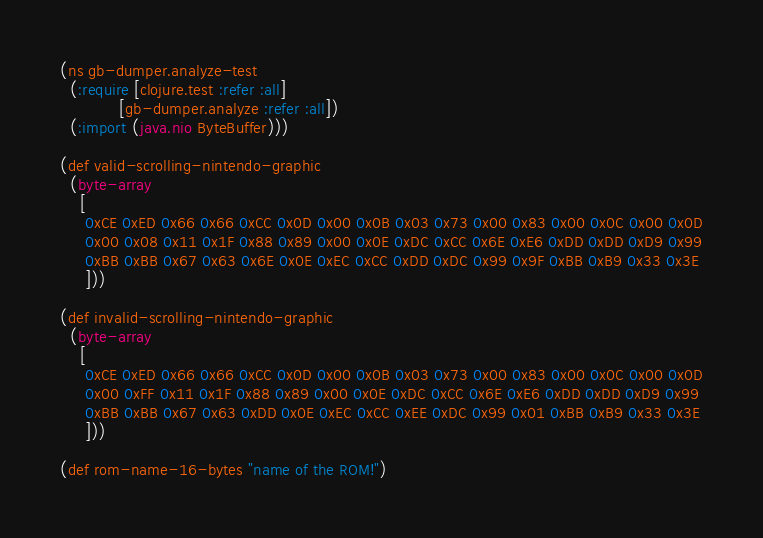<code> <loc_0><loc_0><loc_500><loc_500><_Clojure_>(ns gb-dumper.analyze-test
  (:require [clojure.test :refer :all]
            [gb-dumper.analyze :refer :all])
  (:import (java.nio ByteBuffer)))

(def valid-scrolling-nintendo-graphic
  (byte-array
    [
     0xCE 0xED 0x66 0x66 0xCC 0x0D 0x00 0x0B 0x03 0x73 0x00 0x83 0x00 0x0C 0x00 0x0D
     0x00 0x08 0x11 0x1F 0x88 0x89 0x00 0x0E 0xDC 0xCC 0x6E 0xE6 0xDD 0xDD 0xD9 0x99
     0xBB 0xBB 0x67 0x63 0x6E 0x0E 0xEC 0xCC 0xDD 0xDC 0x99 0x9F 0xBB 0xB9 0x33 0x3E
     ]))

(def invalid-scrolling-nintendo-graphic
  (byte-array
    [
     0xCE 0xED 0x66 0x66 0xCC 0x0D 0x00 0x0B 0x03 0x73 0x00 0x83 0x00 0x0C 0x00 0x0D
     0x00 0xFF 0x11 0x1F 0x88 0x89 0x00 0x0E 0xDC 0xCC 0x6E 0xE6 0xDD 0xDD 0xD9 0x99
     0xBB 0xBB 0x67 0x63 0xDD 0x0E 0xEC 0xCC 0xEE 0xDC 0x99 0x01 0xBB 0xB9 0x33 0x3E
     ]))

(def rom-name-16-bytes "name of the ROM!")
</code> 